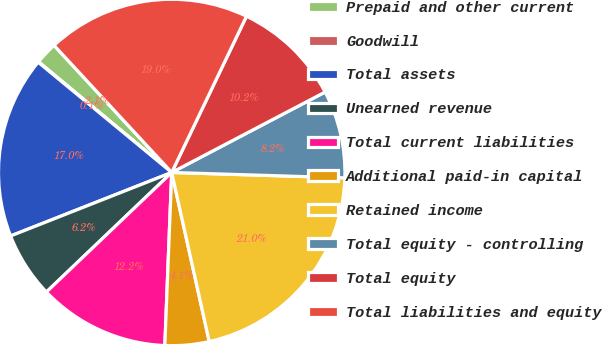Convert chart. <chart><loc_0><loc_0><loc_500><loc_500><pie_chart><fcel>Prepaid and other current<fcel>Goodwill<fcel>Total assets<fcel>Unearned revenue<fcel>Total current liabilities<fcel>Additional paid-in capital<fcel>Retained income<fcel>Total equity - controlling<fcel>Total equity<fcel>Total liabilities and equity<nl><fcel>2.08%<fcel>0.05%<fcel>16.96%<fcel>6.15%<fcel>12.24%<fcel>4.11%<fcel>21.03%<fcel>8.18%<fcel>10.21%<fcel>18.99%<nl></chart> 